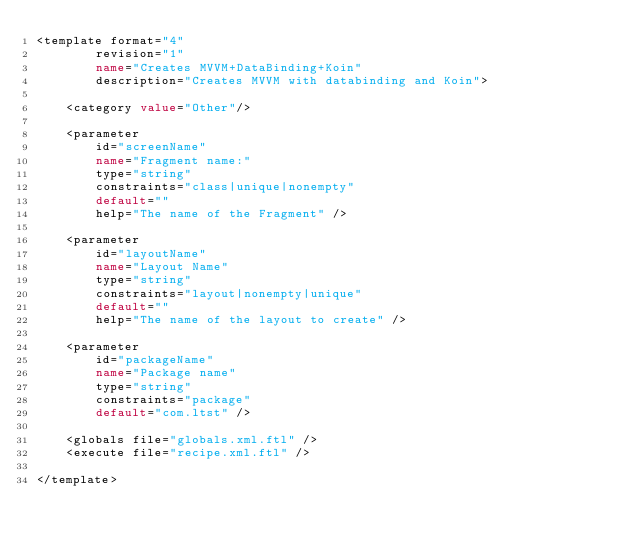<code> <loc_0><loc_0><loc_500><loc_500><_XML_><template format="4"
        revision="1"
        name="Creates MVVM+DataBinding+Koin"
        description="Creates MVVM with databinding and Koin">

    <category value="Other"/>

    <parameter
        id="screenName"
        name="Fragment name:"
        type="string"
        constraints="class|unique|nonempty"
        default=""
        help="The name of the Fragment" />

    <parameter
        id="layoutName"
        name="Layout Name"
        type="string"
        constraints="layout|nonempty|unique"
        default=""
        help="The name of the layout to create" />

    <parameter
        id="packageName"
        name="Package name"
        type="string"
        constraints="package"
        default="com.ltst" />

    <globals file="globals.xml.ftl" />
    <execute file="recipe.xml.ftl" />

</template></code> 